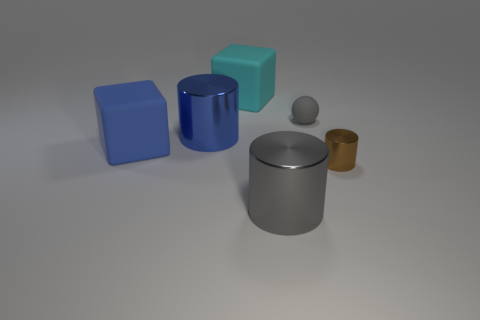How many other large metal things are the same shape as the blue shiny thing?
Your answer should be very brief. 1. What color is the other matte cube that is the same size as the blue cube?
Provide a short and direct response. Cyan. Are there an equal number of tiny matte things to the left of the cyan block and brown things left of the small rubber ball?
Offer a very short reply. Yes. Is there another brown shiny object of the same size as the brown thing?
Provide a succinct answer. No. What size is the brown thing?
Provide a short and direct response. Small. Are there the same number of rubber objects that are in front of the gray matte ball and tiny cylinders?
Give a very brief answer. Yes. What number of other objects are the same color as the tiny shiny object?
Give a very brief answer. 0. There is a metallic object that is both behind the large gray thing and to the left of the tiny brown metallic cylinder; what color is it?
Provide a succinct answer. Blue. There is a matte thing that is left of the big rubber thing right of the matte thing that is on the left side of the blue shiny thing; how big is it?
Offer a very short reply. Large. What number of objects are either metal cylinders that are right of the big blue cylinder or large things to the left of the blue shiny thing?
Make the answer very short. 3. 